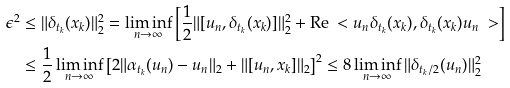<formula> <loc_0><loc_0><loc_500><loc_500>\epsilon ^ { 2 } & \leq \| \delta _ { t _ { k } } ( x _ { k } ) \| _ { 2 } ^ { 2 } = \liminf _ { n \to \infty } \left [ \frac { 1 } { 2 } \| [ u _ { n } , \delta _ { t _ { k } } ( x _ { k } ) ] \| _ { 2 } ^ { 2 } + \text {Re} \ < u _ { n } \delta _ { t _ { k } } ( x _ { k } ) , \delta _ { t _ { k } } ( x _ { k } ) u _ { n } \ > \right ] \\ & \leq \frac { 1 } { 2 } \liminf _ { n \to \infty } \left [ 2 \| \alpha _ { t _ { k } } ( u _ { n } ) - u _ { n } \| _ { 2 } + \| [ u _ { n } , x _ { k } ] \| _ { 2 } \right ] ^ { 2 } \leq 8 \liminf _ { n \to \infty } \| \delta _ { t _ { k } / 2 } ( u _ { n } ) \| _ { 2 } ^ { 2 }</formula> 